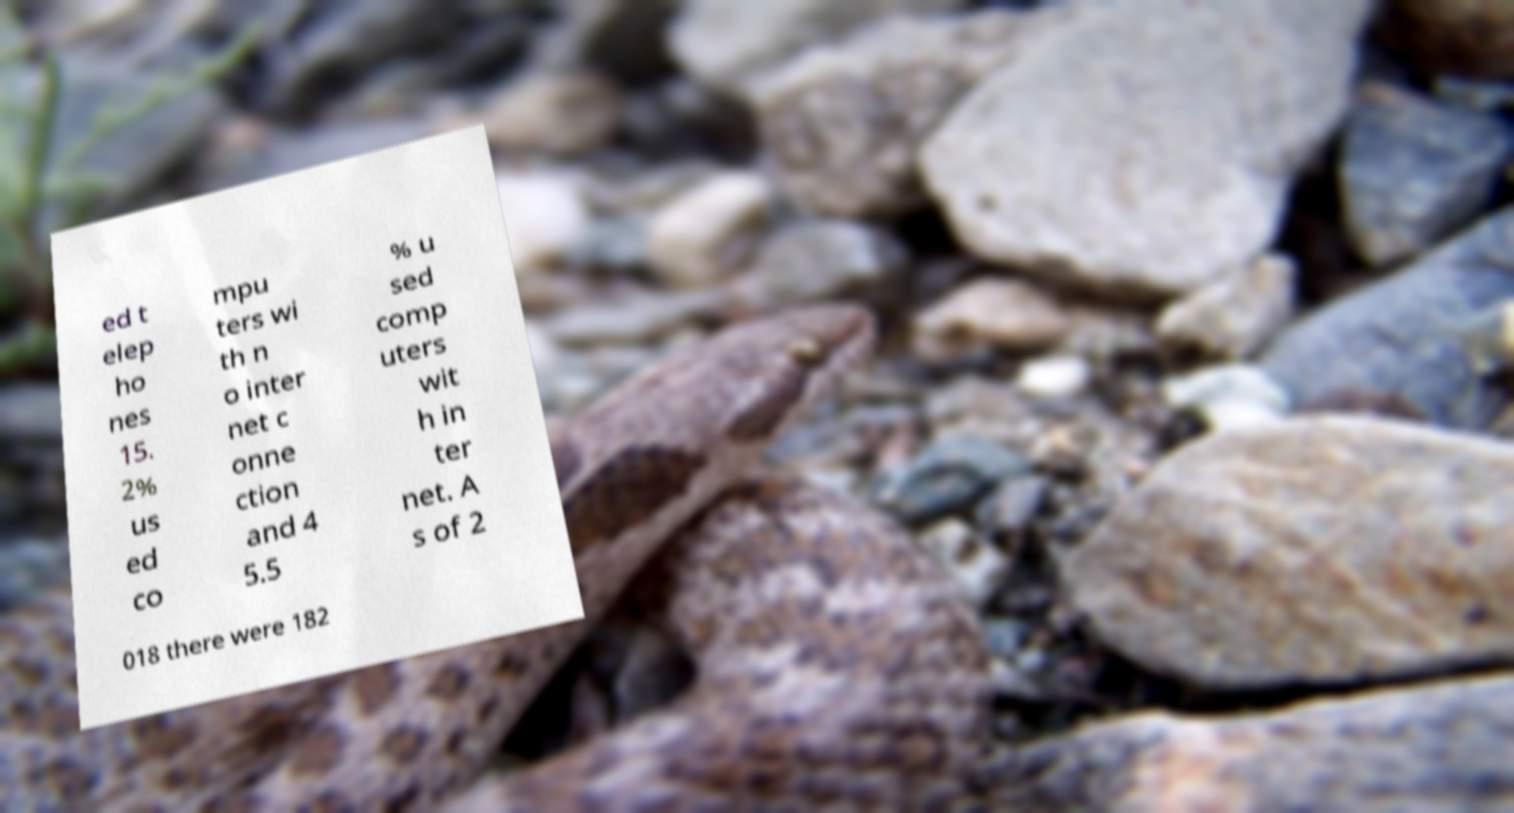Please read and relay the text visible in this image. What does it say? ed t elep ho nes 15. 2% us ed co mpu ters wi th n o inter net c onne ction and 4 5.5 % u sed comp uters wit h in ter net. A s of 2 018 there were 182 